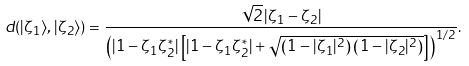Convert formula to latex. <formula><loc_0><loc_0><loc_500><loc_500>d ( | \zeta _ { 1 } \rangle , | \zeta _ { 2 } \rangle ) = \frac { \sqrt { 2 } \, | \zeta _ { 1 } - \zeta _ { 2 } | } { \left ( | 1 - \zeta _ { 1 } \zeta _ { 2 } ^ { * } | \left [ | 1 - \zeta _ { 1 } \zeta _ { 2 } ^ { * } | + \sqrt { \left ( 1 - | \zeta _ { 1 } | ^ { 2 } \right ) \left ( 1 - | \zeta _ { 2 } | ^ { 2 } \right ) } \right ] \right ) ^ { 1 / 2 } } .</formula> 